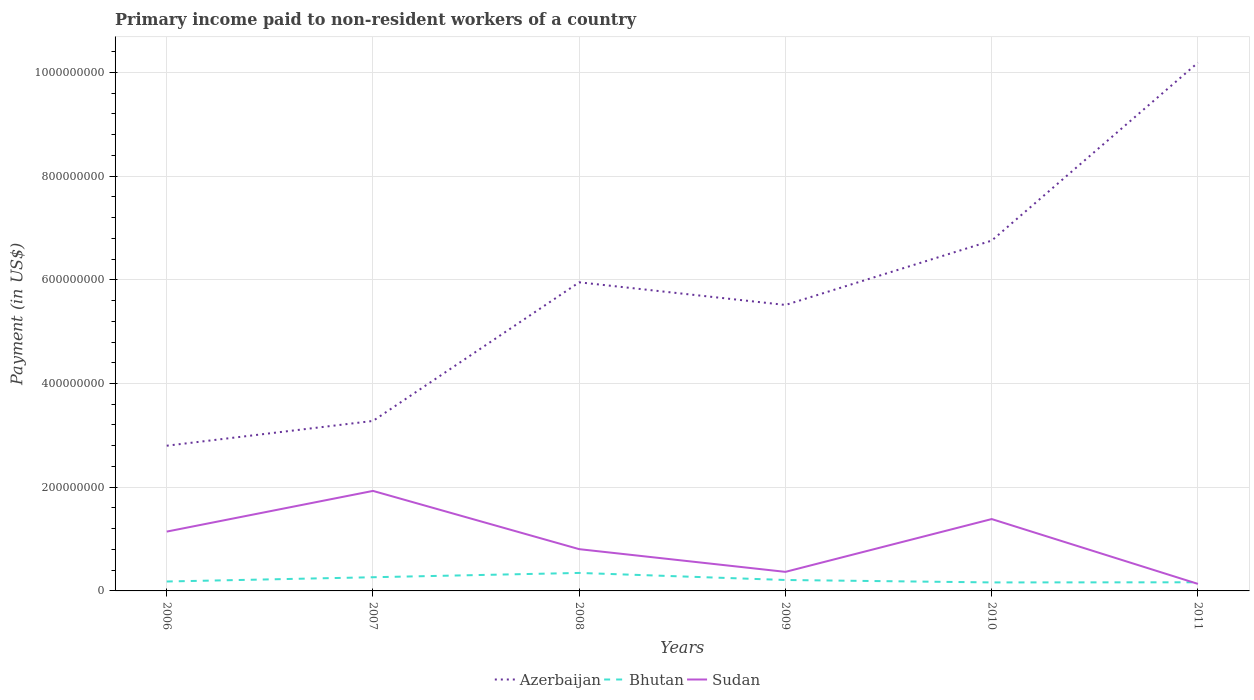Is the number of lines equal to the number of legend labels?
Offer a very short reply. Yes. Across all years, what is the maximum amount paid to workers in Bhutan?
Offer a very short reply. 1.64e+07. In which year was the amount paid to workers in Bhutan maximum?
Your answer should be very brief. 2010. What is the total amount paid to workers in Azerbaijan in the graph?
Your answer should be compact. -2.24e+08. What is the difference between the highest and the second highest amount paid to workers in Bhutan?
Provide a short and direct response. 1.83e+07. What is the difference between the highest and the lowest amount paid to workers in Azerbaijan?
Keep it short and to the point. 3. Is the amount paid to workers in Bhutan strictly greater than the amount paid to workers in Azerbaijan over the years?
Give a very brief answer. Yes. What is the difference between two consecutive major ticks on the Y-axis?
Keep it short and to the point. 2.00e+08. Does the graph contain any zero values?
Offer a terse response. No. Does the graph contain grids?
Your answer should be compact. Yes. How many legend labels are there?
Make the answer very short. 3. What is the title of the graph?
Your response must be concise. Primary income paid to non-resident workers of a country. Does "Pacific island small states" appear as one of the legend labels in the graph?
Offer a terse response. No. What is the label or title of the Y-axis?
Offer a terse response. Payment (in US$). What is the Payment (in US$) in Azerbaijan in 2006?
Your response must be concise. 2.80e+08. What is the Payment (in US$) in Bhutan in 2006?
Make the answer very short. 1.82e+07. What is the Payment (in US$) of Sudan in 2006?
Your answer should be very brief. 1.14e+08. What is the Payment (in US$) in Azerbaijan in 2007?
Provide a short and direct response. 3.28e+08. What is the Payment (in US$) in Bhutan in 2007?
Make the answer very short. 2.64e+07. What is the Payment (in US$) in Sudan in 2007?
Make the answer very short. 1.93e+08. What is the Payment (in US$) of Azerbaijan in 2008?
Ensure brevity in your answer.  5.95e+08. What is the Payment (in US$) in Bhutan in 2008?
Offer a very short reply. 3.47e+07. What is the Payment (in US$) in Sudan in 2008?
Make the answer very short. 8.05e+07. What is the Payment (in US$) of Azerbaijan in 2009?
Provide a short and direct response. 5.51e+08. What is the Payment (in US$) in Bhutan in 2009?
Provide a succinct answer. 2.11e+07. What is the Payment (in US$) in Sudan in 2009?
Provide a short and direct response. 3.67e+07. What is the Payment (in US$) in Azerbaijan in 2010?
Offer a very short reply. 6.76e+08. What is the Payment (in US$) in Bhutan in 2010?
Keep it short and to the point. 1.64e+07. What is the Payment (in US$) of Sudan in 2010?
Ensure brevity in your answer.  1.39e+08. What is the Payment (in US$) in Azerbaijan in 2011?
Ensure brevity in your answer.  1.02e+09. What is the Payment (in US$) of Bhutan in 2011?
Your answer should be compact. 1.66e+07. What is the Payment (in US$) of Sudan in 2011?
Your answer should be very brief. 1.35e+07. Across all years, what is the maximum Payment (in US$) of Azerbaijan?
Your response must be concise. 1.02e+09. Across all years, what is the maximum Payment (in US$) of Bhutan?
Offer a very short reply. 3.47e+07. Across all years, what is the maximum Payment (in US$) of Sudan?
Offer a terse response. 1.93e+08. Across all years, what is the minimum Payment (in US$) in Azerbaijan?
Ensure brevity in your answer.  2.80e+08. Across all years, what is the minimum Payment (in US$) in Bhutan?
Provide a succinct answer. 1.64e+07. Across all years, what is the minimum Payment (in US$) of Sudan?
Offer a terse response. 1.35e+07. What is the total Payment (in US$) in Azerbaijan in the graph?
Make the answer very short. 3.45e+09. What is the total Payment (in US$) in Bhutan in the graph?
Offer a very short reply. 1.33e+08. What is the total Payment (in US$) in Sudan in the graph?
Provide a succinct answer. 5.77e+08. What is the difference between the Payment (in US$) of Azerbaijan in 2006 and that in 2007?
Provide a short and direct response. -4.78e+07. What is the difference between the Payment (in US$) in Bhutan in 2006 and that in 2007?
Ensure brevity in your answer.  -8.22e+06. What is the difference between the Payment (in US$) of Sudan in 2006 and that in 2007?
Your answer should be compact. -7.85e+07. What is the difference between the Payment (in US$) of Azerbaijan in 2006 and that in 2008?
Your answer should be compact. -3.15e+08. What is the difference between the Payment (in US$) in Bhutan in 2006 and that in 2008?
Ensure brevity in your answer.  -1.65e+07. What is the difference between the Payment (in US$) in Sudan in 2006 and that in 2008?
Make the answer very short. 3.39e+07. What is the difference between the Payment (in US$) in Azerbaijan in 2006 and that in 2009?
Your answer should be compact. -2.71e+08. What is the difference between the Payment (in US$) of Bhutan in 2006 and that in 2009?
Make the answer very short. -2.90e+06. What is the difference between the Payment (in US$) in Sudan in 2006 and that in 2009?
Your answer should be compact. 7.76e+07. What is the difference between the Payment (in US$) of Azerbaijan in 2006 and that in 2010?
Keep it short and to the point. -3.96e+08. What is the difference between the Payment (in US$) in Bhutan in 2006 and that in 2010?
Your response must be concise. 1.79e+06. What is the difference between the Payment (in US$) of Sudan in 2006 and that in 2010?
Ensure brevity in your answer.  -2.42e+07. What is the difference between the Payment (in US$) in Azerbaijan in 2006 and that in 2011?
Give a very brief answer. -7.39e+08. What is the difference between the Payment (in US$) in Bhutan in 2006 and that in 2011?
Give a very brief answer. 1.53e+06. What is the difference between the Payment (in US$) of Sudan in 2006 and that in 2011?
Your answer should be compact. 1.01e+08. What is the difference between the Payment (in US$) of Azerbaijan in 2007 and that in 2008?
Make the answer very short. -2.67e+08. What is the difference between the Payment (in US$) in Bhutan in 2007 and that in 2008?
Offer a very short reply. -8.30e+06. What is the difference between the Payment (in US$) in Sudan in 2007 and that in 2008?
Provide a succinct answer. 1.12e+08. What is the difference between the Payment (in US$) in Azerbaijan in 2007 and that in 2009?
Give a very brief answer. -2.24e+08. What is the difference between the Payment (in US$) of Bhutan in 2007 and that in 2009?
Give a very brief answer. 5.32e+06. What is the difference between the Payment (in US$) of Sudan in 2007 and that in 2009?
Provide a short and direct response. 1.56e+08. What is the difference between the Payment (in US$) in Azerbaijan in 2007 and that in 2010?
Your answer should be compact. -3.48e+08. What is the difference between the Payment (in US$) in Bhutan in 2007 and that in 2010?
Your answer should be very brief. 1.00e+07. What is the difference between the Payment (in US$) of Sudan in 2007 and that in 2010?
Your answer should be very brief. 5.43e+07. What is the difference between the Payment (in US$) of Azerbaijan in 2007 and that in 2011?
Keep it short and to the point. -6.91e+08. What is the difference between the Payment (in US$) in Bhutan in 2007 and that in 2011?
Provide a short and direct response. 9.75e+06. What is the difference between the Payment (in US$) of Sudan in 2007 and that in 2011?
Make the answer very short. 1.79e+08. What is the difference between the Payment (in US$) of Azerbaijan in 2008 and that in 2009?
Provide a succinct answer. 4.37e+07. What is the difference between the Payment (in US$) of Bhutan in 2008 and that in 2009?
Offer a very short reply. 1.36e+07. What is the difference between the Payment (in US$) in Sudan in 2008 and that in 2009?
Make the answer very short. 4.38e+07. What is the difference between the Payment (in US$) in Azerbaijan in 2008 and that in 2010?
Your response must be concise. -8.04e+07. What is the difference between the Payment (in US$) of Bhutan in 2008 and that in 2010?
Ensure brevity in your answer.  1.83e+07. What is the difference between the Payment (in US$) of Sudan in 2008 and that in 2010?
Provide a succinct answer. -5.81e+07. What is the difference between the Payment (in US$) of Azerbaijan in 2008 and that in 2011?
Offer a terse response. -4.24e+08. What is the difference between the Payment (in US$) of Bhutan in 2008 and that in 2011?
Provide a succinct answer. 1.80e+07. What is the difference between the Payment (in US$) in Sudan in 2008 and that in 2011?
Your answer should be very brief. 6.70e+07. What is the difference between the Payment (in US$) in Azerbaijan in 2009 and that in 2010?
Give a very brief answer. -1.24e+08. What is the difference between the Payment (in US$) in Bhutan in 2009 and that in 2010?
Provide a short and direct response. 4.68e+06. What is the difference between the Payment (in US$) in Sudan in 2009 and that in 2010?
Offer a very short reply. -1.02e+08. What is the difference between the Payment (in US$) in Azerbaijan in 2009 and that in 2011?
Your response must be concise. -4.67e+08. What is the difference between the Payment (in US$) in Bhutan in 2009 and that in 2011?
Offer a terse response. 4.43e+06. What is the difference between the Payment (in US$) of Sudan in 2009 and that in 2011?
Offer a terse response. 2.32e+07. What is the difference between the Payment (in US$) in Azerbaijan in 2010 and that in 2011?
Keep it short and to the point. -3.43e+08. What is the difference between the Payment (in US$) in Bhutan in 2010 and that in 2011?
Ensure brevity in your answer.  -2.57e+05. What is the difference between the Payment (in US$) of Sudan in 2010 and that in 2011?
Offer a very short reply. 1.25e+08. What is the difference between the Payment (in US$) in Azerbaijan in 2006 and the Payment (in US$) in Bhutan in 2007?
Make the answer very short. 2.54e+08. What is the difference between the Payment (in US$) in Azerbaijan in 2006 and the Payment (in US$) in Sudan in 2007?
Offer a very short reply. 8.71e+07. What is the difference between the Payment (in US$) in Bhutan in 2006 and the Payment (in US$) in Sudan in 2007?
Offer a terse response. -1.75e+08. What is the difference between the Payment (in US$) of Azerbaijan in 2006 and the Payment (in US$) of Bhutan in 2008?
Offer a terse response. 2.45e+08. What is the difference between the Payment (in US$) of Azerbaijan in 2006 and the Payment (in US$) of Sudan in 2008?
Offer a very short reply. 2.00e+08. What is the difference between the Payment (in US$) of Bhutan in 2006 and the Payment (in US$) of Sudan in 2008?
Your answer should be compact. -6.23e+07. What is the difference between the Payment (in US$) in Azerbaijan in 2006 and the Payment (in US$) in Bhutan in 2009?
Offer a terse response. 2.59e+08. What is the difference between the Payment (in US$) in Azerbaijan in 2006 and the Payment (in US$) in Sudan in 2009?
Offer a terse response. 2.43e+08. What is the difference between the Payment (in US$) in Bhutan in 2006 and the Payment (in US$) in Sudan in 2009?
Offer a very short reply. -1.86e+07. What is the difference between the Payment (in US$) in Azerbaijan in 2006 and the Payment (in US$) in Bhutan in 2010?
Provide a succinct answer. 2.64e+08. What is the difference between the Payment (in US$) of Azerbaijan in 2006 and the Payment (in US$) of Sudan in 2010?
Provide a succinct answer. 1.41e+08. What is the difference between the Payment (in US$) of Bhutan in 2006 and the Payment (in US$) of Sudan in 2010?
Your answer should be very brief. -1.20e+08. What is the difference between the Payment (in US$) of Azerbaijan in 2006 and the Payment (in US$) of Bhutan in 2011?
Your answer should be compact. 2.63e+08. What is the difference between the Payment (in US$) in Azerbaijan in 2006 and the Payment (in US$) in Sudan in 2011?
Provide a short and direct response. 2.66e+08. What is the difference between the Payment (in US$) in Bhutan in 2006 and the Payment (in US$) in Sudan in 2011?
Offer a very short reply. 4.63e+06. What is the difference between the Payment (in US$) of Azerbaijan in 2007 and the Payment (in US$) of Bhutan in 2008?
Ensure brevity in your answer.  2.93e+08. What is the difference between the Payment (in US$) in Azerbaijan in 2007 and the Payment (in US$) in Sudan in 2008?
Your answer should be very brief. 2.47e+08. What is the difference between the Payment (in US$) of Bhutan in 2007 and the Payment (in US$) of Sudan in 2008?
Your answer should be very brief. -5.41e+07. What is the difference between the Payment (in US$) of Azerbaijan in 2007 and the Payment (in US$) of Bhutan in 2009?
Make the answer very short. 3.07e+08. What is the difference between the Payment (in US$) of Azerbaijan in 2007 and the Payment (in US$) of Sudan in 2009?
Give a very brief answer. 2.91e+08. What is the difference between the Payment (in US$) of Bhutan in 2007 and the Payment (in US$) of Sudan in 2009?
Your answer should be compact. -1.03e+07. What is the difference between the Payment (in US$) of Azerbaijan in 2007 and the Payment (in US$) of Bhutan in 2010?
Your answer should be very brief. 3.11e+08. What is the difference between the Payment (in US$) in Azerbaijan in 2007 and the Payment (in US$) in Sudan in 2010?
Offer a terse response. 1.89e+08. What is the difference between the Payment (in US$) of Bhutan in 2007 and the Payment (in US$) of Sudan in 2010?
Give a very brief answer. -1.12e+08. What is the difference between the Payment (in US$) of Azerbaijan in 2007 and the Payment (in US$) of Bhutan in 2011?
Give a very brief answer. 3.11e+08. What is the difference between the Payment (in US$) of Azerbaijan in 2007 and the Payment (in US$) of Sudan in 2011?
Give a very brief answer. 3.14e+08. What is the difference between the Payment (in US$) of Bhutan in 2007 and the Payment (in US$) of Sudan in 2011?
Provide a short and direct response. 1.28e+07. What is the difference between the Payment (in US$) of Azerbaijan in 2008 and the Payment (in US$) of Bhutan in 2009?
Provide a succinct answer. 5.74e+08. What is the difference between the Payment (in US$) in Azerbaijan in 2008 and the Payment (in US$) in Sudan in 2009?
Provide a succinct answer. 5.58e+08. What is the difference between the Payment (in US$) in Bhutan in 2008 and the Payment (in US$) in Sudan in 2009?
Provide a short and direct response. -2.05e+06. What is the difference between the Payment (in US$) of Azerbaijan in 2008 and the Payment (in US$) of Bhutan in 2010?
Offer a very short reply. 5.79e+08. What is the difference between the Payment (in US$) in Azerbaijan in 2008 and the Payment (in US$) in Sudan in 2010?
Offer a terse response. 4.57e+08. What is the difference between the Payment (in US$) in Bhutan in 2008 and the Payment (in US$) in Sudan in 2010?
Ensure brevity in your answer.  -1.04e+08. What is the difference between the Payment (in US$) of Azerbaijan in 2008 and the Payment (in US$) of Bhutan in 2011?
Provide a succinct answer. 5.78e+08. What is the difference between the Payment (in US$) of Azerbaijan in 2008 and the Payment (in US$) of Sudan in 2011?
Make the answer very short. 5.82e+08. What is the difference between the Payment (in US$) in Bhutan in 2008 and the Payment (in US$) in Sudan in 2011?
Keep it short and to the point. 2.12e+07. What is the difference between the Payment (in US$) of Azerbaijan in 2009 and the Payment (in US$) of Bhutan in 2010?
Make the answer very short. 5.35e+08. What is the difference between the Payment (in US$) of Azerbaijan in 2009 and the Payment (in US$) of Sudan in 2010?
Keep it short and to the point. 4.13e+08. What is the difference between the Payment (in US$) in Bhutan in 2009 and the Payment (in US$) in Sudan in 2010?
Give a very brief answer. -1.18e+08. What is the difference between the Payment (in US$) of Azerbaijan in 2009 and the Payment (in US$) of Bhutan in 2011?
Provide a succinct answer. 5.35e+08. What is the difference between the Payment (in US$) of Azerbaijan in 2009 and the Payment (in US$) of Sudan in 2011?
Keep it short and to the point. 5.38e+08. What is the difference between the Payment (in US$) of Bhutan in 2009 and the Payment (in US$) of Sudan in 2011?
Keep it short and to the point. 7.53e+06. What is the difference between the Payment (in US$) in Azerbaijan in 2010 and the Payment (in US$) in Bhutan in 2011?
Provide a succinct answer. 6.59e+08. What is the difference between the Payment (in US$) in Azerbaijan in 2010 and the Payment (in US$) in Sudan in 2011?
Provide a succinct answer. 6.62e+08. What is the difference between the Payment (in US$) of Bhutan in 2010 and the Payment (in US$) of Sudan in 2011?
Offer a terse response. 2.84e+06. What is the average Payment (in US$) of Azerbaijan per year?
Give a very brief answer. 5.75e+08. What is the average Payment (in US$) in Bhutan per year?
Keep it short and to the point. 2.22e+07. What is the average Payment (in US$) of Sudan per year?
Offer a very short reply. 9.61e+07. In the year 2006, what is the difference between the Payment (in US$) in Azerbaijan and Payment (in US$) in Bhutan?
Offer a very short reply. 2.62e+08. In the year 2006, what is the difference between the Payment (in US$) of Azerbaijan and Payment (in US$) of Sudan?
Your response must be concise. 1.66e+08. In the year 2006, what is the difference between the Payment (in US$) in Bhutan and Payment (in US$) in Sudan?
Ensure brevity in your answer.  -9.62e+07. In the year 2007, what is the difference between the Payment (in US$) of Azerbaijan and Payment (in US$) of Bhutan?
Keep it short and to the point. 3.01e+08. In the year 2007, what is the difference between the Payment (in US$) of Azerbaijan and Payment (in US$) of Sudan?
Give a very brief answer. 1.35e+08. In the year 2007, what is the difference between the Payment (in US$) of Bhutan and Payment (in US$) of Sudan?
Your answer should be very brief. -1.66e+08. In the year 2008, what is the difference between the Payment (in US$) of Azerbaijan and Payment (in US$) of Bhutan?
Offer a terse response. 5.60e+08. In the year 2008, what is the difference between the Payment (in US$) of Azerbaijan and Payment (in US$) of Sudan?
Keep it short and to the point. 5.15e+08. In the year 2008, what is the difference between the Payment (in US$) of Bhutan and Payment (in US$) of Sudan?
Make the answer very short. -4.58e+07. In the year 2009, what is the difference between the Payment (in US$) in Azerbaijan and Payment (in US$) in Bhutan?
Keep it short and to the point. 5.30e+08. In the year 2009, what is the difference between the Payment (in US$) in Azerbaijan and Payment (in US$) in Sudan?
Your response must be concise. 5.15e+08. In the year 2009, what is the difference between the Payment (in US$) in Bhutan and Payment (in US$) in Sudan?
Offer a very short reply. -1.57e+07. In the year 2010, what is the difference between the Payment (in US$) in Azerbaijan and Payment (in US$) in Bhutan?
Keep it short and to the point. 6.59e+08. In the year 2010, what is the difference between the Payment (in US$) in Azerbaijan and Payment (in US$) in Sudan?
Your answer should be very brief. 5.37e+08. In the year 2010, what is the difference between the Payment (in US$) in Bhutan and Payment (in US$) in Sudan?
Keep it short and to the point. -1.22e+08. In the year 2011, what is the difference between the Payment (in US$) of Azerbaijan and Payment (in US$) of Bhutan?
Your answer should be very brief. 1.00e+09. In the year 2011, what is the difference between the Payment (in US$) of Azerbaijan and Payment (in US$) of Sudan?
Your response must be concise. 1.01e+09. In the year 2011, what is the difference between the Payment (in US$) of Bhutan and Payment (in US$) of Sudan?
Give a very brief answer. 3.10e+06. What is the ratio of the Payment (in US$) of Azerbaijan in 2006 to that in 2007?
Keep it short and to the point. 0.85. What is the ratio of the Payment (in US$) in Bhutan in 2006 to that in 2007?
Offer a very short reply. 0.69. What is the ratio of the Payment (in US$) in Sudan in 2006 to that in 2007?
Keep it short and to the point. 0.59. What is the ratio of the Payment (in US$) in Azerbaijan in 2006 to that in 2008?
Provide a short and direct response. 0.47. What is the ratio of the Payment (in US$) of Bhutan in 2006 to that in 2008?
Your answer should be very brief. 0.52. What is the ratio of the Payment (in US$) in Sudan in 2006 to that in 2008?
Provide a succinct answer. 1.42. What is the ratio of the Payment (in US$) in Azerbaijan in 2006 to that in 2009?
Offer a terse response. 0.51. What is the ratio of the Payment (in US$) of Bhutan in 2006 to that in 2009?
Offer a very short reply. 0.86. What is the ratio of the Payment (in US$) of Sudan in 2006 to that in 2009?
Your response must be concise. 3.11. What is the ratio of the Payment (in US$) in Azerbaijan in 2006 to that in 2010?
Provide a succinct answer. 0.41. What is the ratio of the Payment (in US$) of Bhutan in 2006 to that in 2010?
Give a very brief answer. 1.11. What is the ratio of the Payment (in US$) of Sudan in 2006 to that in 2010?
Make the answer very short. 0.83. What is the ratio of the Payment (in US$) of Azerbaijan in 2006 to that in 2011?
Your response must be concise. 0.27. What is the ratio of the Payment (in US$) in Bhutan in 2006 to that in 2011?
Your response must be concise. 1.09. What is the ratio of the Payment (in US$) of Sudan in 2006 to that in 2011?
Provide a succinct answer. 8.44. What is the ratio of the Payment (in US$) of Azerbaijan in 2007 to that in 2008?
Offer a terse response. 0.55. What is the ratio of the Payment (in US$) of Bhutan in 2007 to that in 2008?
Give a very brief answer. 0.76. What is the ratio of the Payment (in US$) in Sudan in 2007 to that in 2008?
Your response must be concise. 2.4. What is the ratio of the Payment (in US$) in Azerbaijan in 2007 to that in 2009?
Your answer should be compact. 0.59. What is the ratio of the Payment (in US$) of Bhutan in 2007 to that in 2009?
Ensure brevity in your answer.  1.25. What is the ratio of the Payment (in US$) in Sudan in 2007 to that in 2009?
Your response must be concise. 5.25. What is the ratio of the Payment (in US$) of Azerbaijan in 2007 to that in 2010?
Give a very brief answer. 0.49. What is the ratio of the Payment (in US$) in Bhutan in 2007 to that in 2010?
Ensure brevity in your answer.  1.61. What is the ratio of the Payment (in US$) in Sudan in 2007 to that in 2010?
Provide a succinct answer. 1.39. What is the ratio of the Payment (in US$) of Azerbaijan in 2007 to that in 2011?
Ensure brevity in your answer.  0.32. What is the ratio of the Payment (in US$) of Bhutan in 2007 to that in 2011?
Ensure brevity in your answer.  1.59. What is the ratio of the Payment (in US$) in Sudan in 2007 to that in 2011?
Your response must be concise. 14.24. What is the ratio of the Payment (in US$) in Azerbaijan in 2008 to that in 2009?
Give a very brief answer. 1.08. What is the ratio of the Payment (in US$) in Bhutan in 2008 to that in 2009?
Your answer should be very brief. 1.65. What is the ratio of the Payment (in US$) of Sudan in 2008 to that in 2009?
Give a very brief answer. 2.19. What is the ratio of the Payment (in US$) of Azerbaijan in 2008 to that in 2010?
Your answer should be compact. 0.88. What is the ratio of the Payment (in US$) of Bhutan in 2008 to that in 2010?
Give a very brief answer. 2.12. What is the ratio of the Payment (in US$) in Sudan in 2008 to that in 2010?
Give a very brief answer. 0.58. What is the ratio of the Payment (in US$) of Azerbaijan in 2008 to that in 2011?
Provide a short and direct response. 0.58. What is the ratio of the Payment (in US$) of Bhutan in 2008 to that in 2011?
Keep it short and to the point. 2.08. What is the ratio of the Payment (in US$) in Sudan in 2008 to that in 2011?
Ensure brevity in your answer.  5.94. What is the ratio of the Payment (in US$) of Azerbaijan in 2009 to that in 2010?
Provide a short and direct response. 0.82. What is the ratio of the Payment (in US$) in Bhutan in 2009 to that in 2010?
Keep it short and to the point. 1.29. What is the ratio of the Payment (in US$) of Sudan in 2009 to that in 2010?
Provide a short and direct response. 0.27. What is the ratio of the Payment (in US$) of Azerbaijan in 2009 to that in 2011?
Give a very brief answer. 0.54. What is the ratio of the Payment (in US$) of Bhutan in 2009 to that in 2011?
Offer a terse response. 1.27. What is the ratio of the Payment (in US$) of Sudan in 2009 to that in 2011?
Keep it short and to the point. 2.71. What is the ratio of the Payment (in US$) of Azerbaijan in 2010 to that in 2011?
Provide a succinct answer. 0.66. What is the ratio of the Payment (in US$) in Bhutan in 2010 to that in 2011?
Offer a terse response. 0.98. What is the ratio of the Payment (in US$) of Sudan in 2010 to that in 2011?
Your answer should be very brief. 10.23. What is the difference between the highest and the second highest Payment (in US$) of Azerbaijan?
Offer a very short reply. 3.43e+08. What is the difference between the highest and the second highest Payment (in US$) in Bhutan?
Your response must be concise. 8.30e+06. What is the difference between the highest and the second highest Payment (in US$) of Sudan?
Your answer should be very brief. 5.43e+07. What is the difference between the highest and the lowest Payment (in US$) in Azerbaijan?
Your response must be concise. 7.39e+08. What is the difference between the highest and the lowest Payment (in US$) in Bhutan?
Provide a succinct answer. 1.83e+07. What is the difference between the highest and the lowest Payment (in US$) in Sudan?
Your answer should be compact. 1.79e+08. 